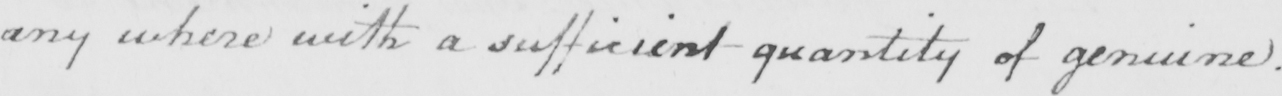Transcribe the text shown in this historical manuscript line. any where with a sufficient quantity of genuine . 